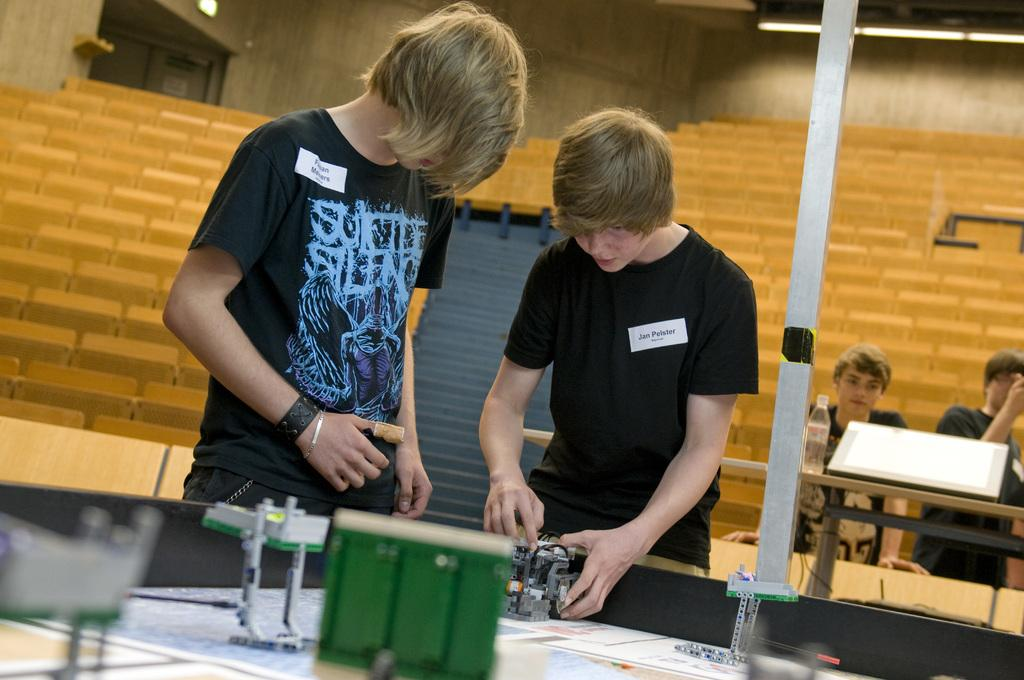What are the two boys in the foreground of the image doing? The two boys in the foreground are standing and doing lab work. How many boys are present in the image in total? There are four boys in the image in total. Can you describe the actions of the boys in the background? The boys in the background are also standing. What type of animal can be seen climbing the tree in the image? There is no tree or animal present in the image; it features boys doing lab work. 